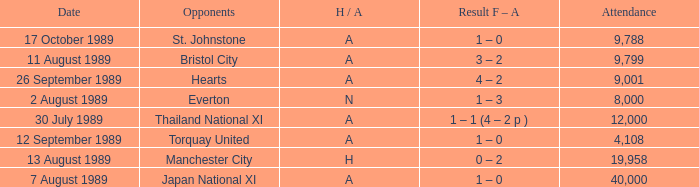During the manchester united vs hearts game, how many individuals were present at the match? 9001.0. 